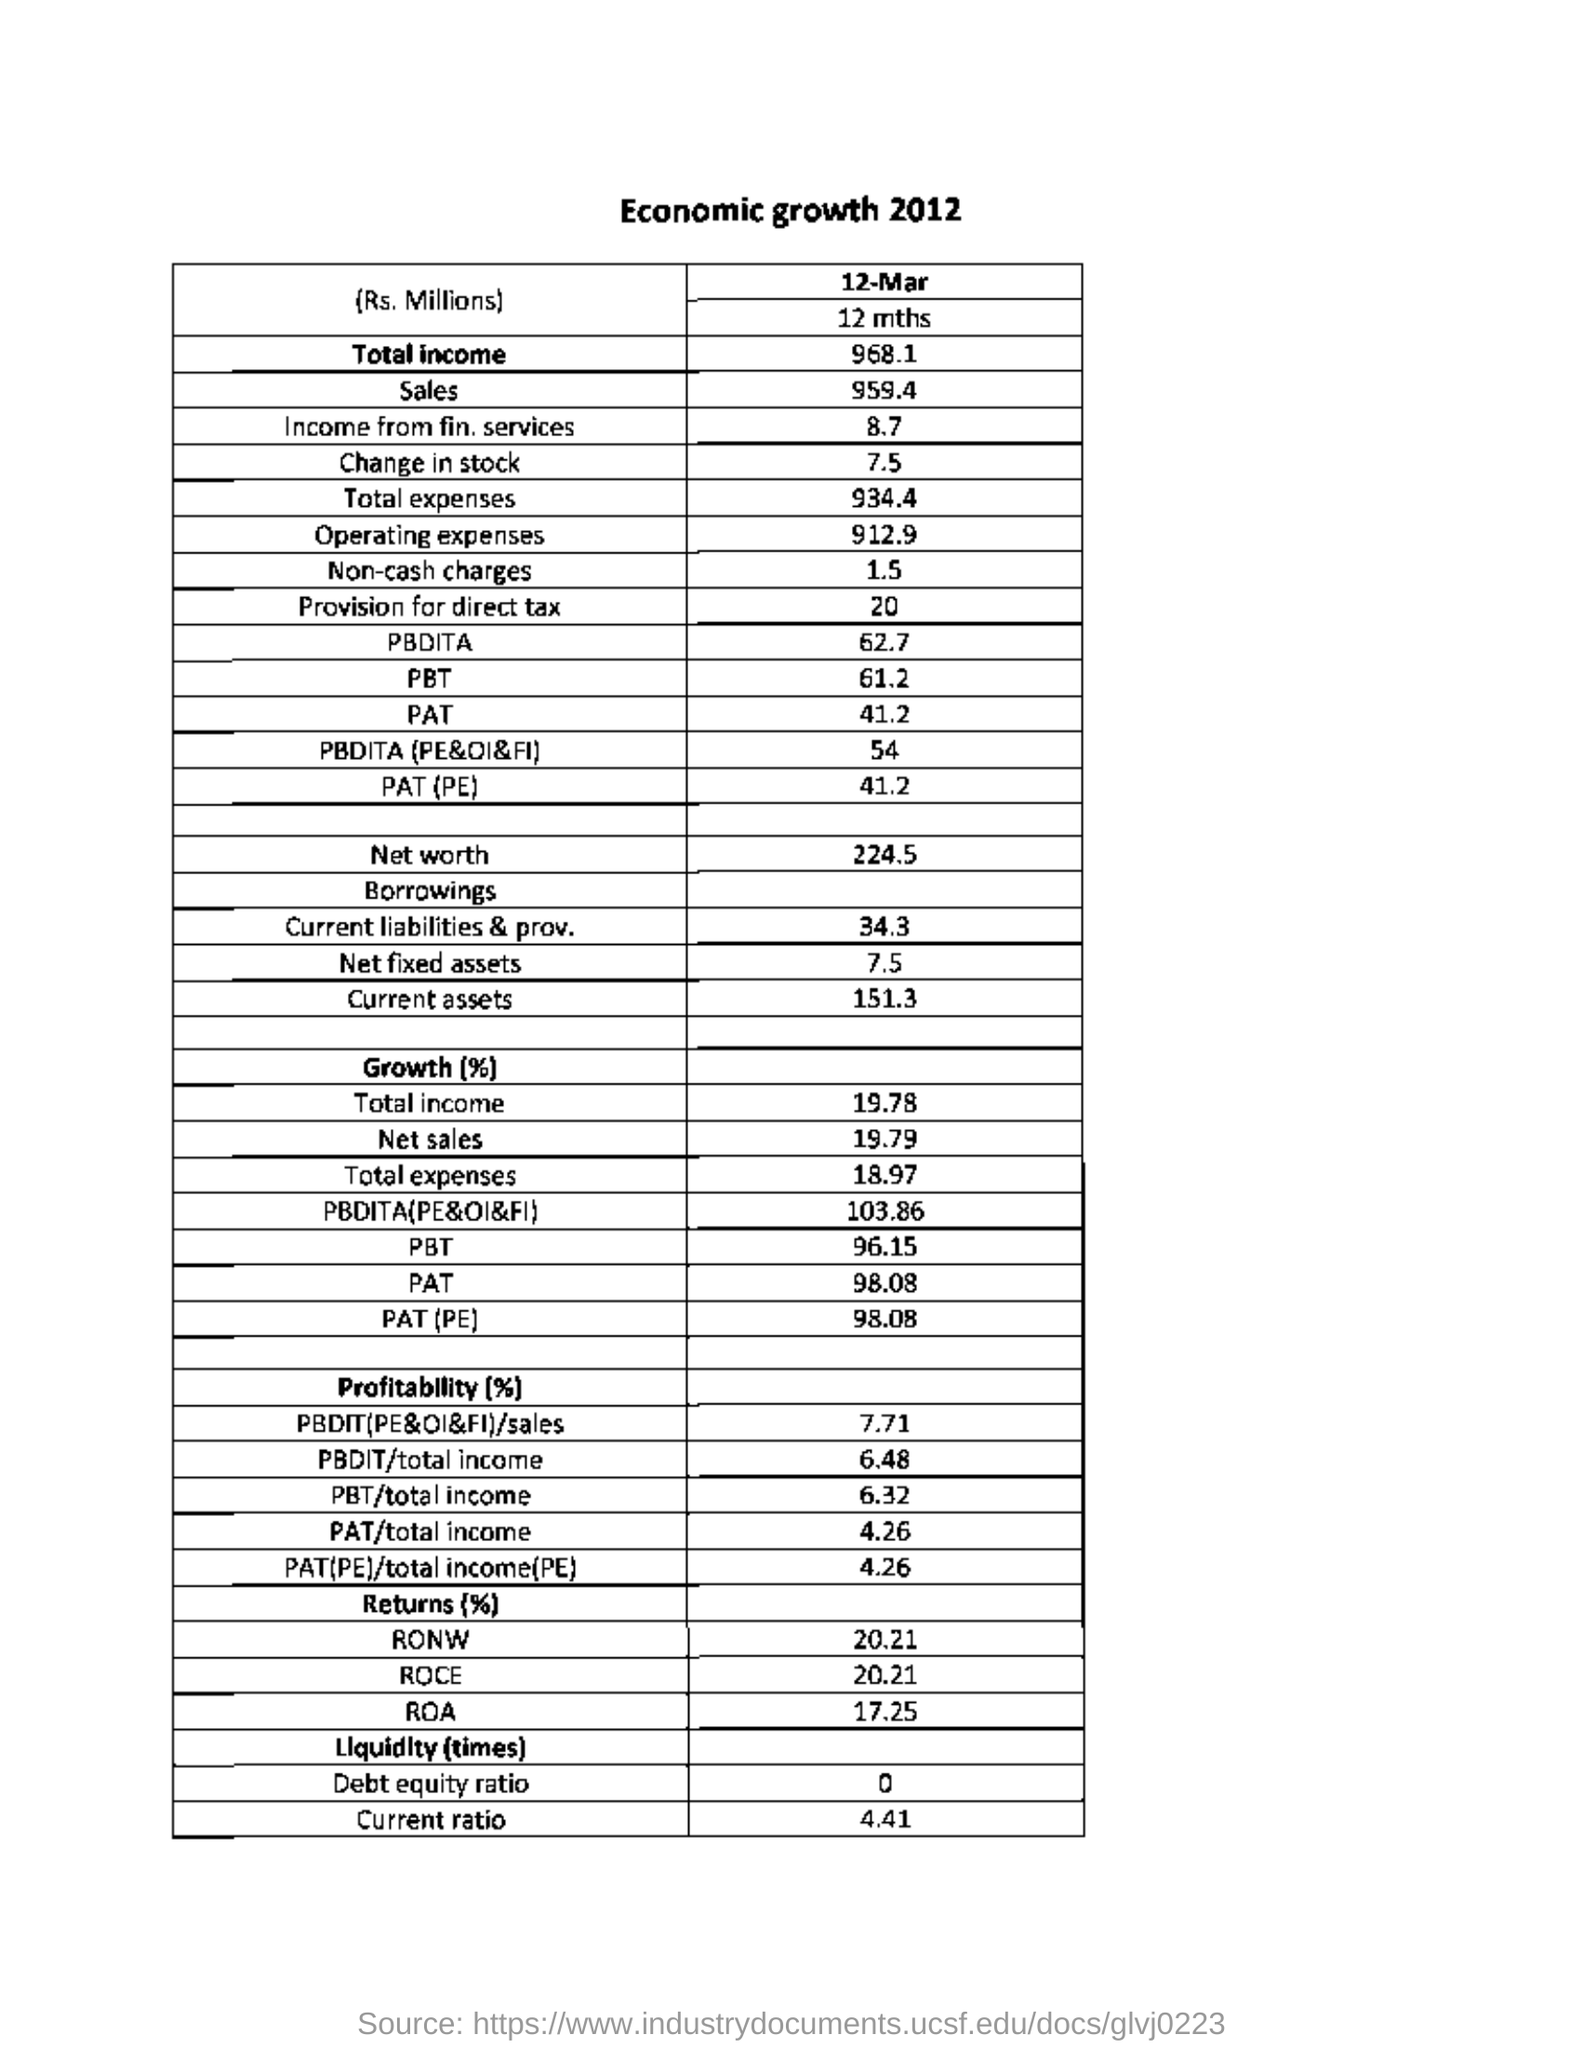What is the heading of the table?
Your answer should be very brief. Economic growth 2012. What is "Income from fin. services" value given ?
Keep it short and to the point. 8.7. What is "Operating expenses" value given?
Your answer should be compact. 912.9. What is "Net fixed assets" value given?
Provide a short and direct response. 7.5. What is "Current assets" value given?
Make the answer very short. 151.3. What is "Total Income" mentioned under Growth (%)?
Give a very brief answer. 19.78. What is "Net sales" mentioned under Growth (%)?
Offer a very short reply. 19.79. What is "PAT/total income" mentioned under Profitability(%)?
Your answer should be compact. 4.26. What is "Debt equity ratio" mentioned under Liquidity (times)?
Ensure brevity in your answer.  0. What is "Current ratio" mentioned under Liquidity (times)?
Provide a short and direct response. 4.41. 